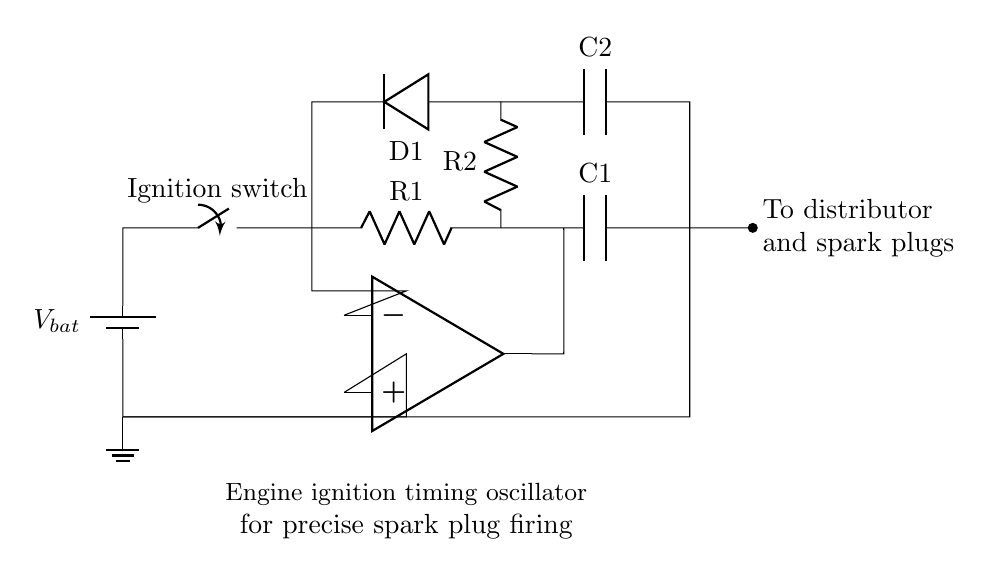What is the main purpose of this circuit? The purpose of the circuit is to serve as an engine ignition timing oscillator for precise spark plug firing, which indicates that it is responsible for controlling when the spark plugs ignite the air-fuel mixture in the engine.
Answer: engine ignition timing oscillator What components are in series with the battery? The ignition switch and resistor R1 are connected in series with the battery, which means that the current flows through these components sequentially from the battery.
Answer: ignition switch, R1 What are the values of the capacitors in the circuit? The values of the capacitors are denoted as C1 and C2 in the circuit diagram. While specific numeric values are not provided visually, we identify these components by their labels.
Answer: C1, C2 What is the expected outcome when D1 is forward-biased? When D1 is forward-biased, it allows current to flow from R2 through D1, enabling the circuit to function correctly by charging the capacitors and influencing the timing of the spark generation.
Answer: current flows What does the op-amp do in this circuit? The op-amp amplifies the voltage difference between its input terminals, thereby playing a critical role in controlling the timing and precision of the spark firing by ensuring that the output is regulated based on the input conditions.
Answer: amplifies voltage difference How is the spark plug firing connected in this circuit? The spark plug firing is connected through a short line that leads from the point marked "To distributor and spark plugs," indicating that the output of the oscillator ultimately controls the ignition system.
Answer: through a short line to distributor 